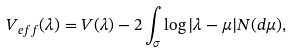<formula> <loc_0><loc_0><loc_500><loc_500>V _ { e f f } ( \lambda ) = V ( \lambda ) - 2 \int _ { \sigma } \log | \lambda - \mu | N ( d \mu ) ,</formula> 